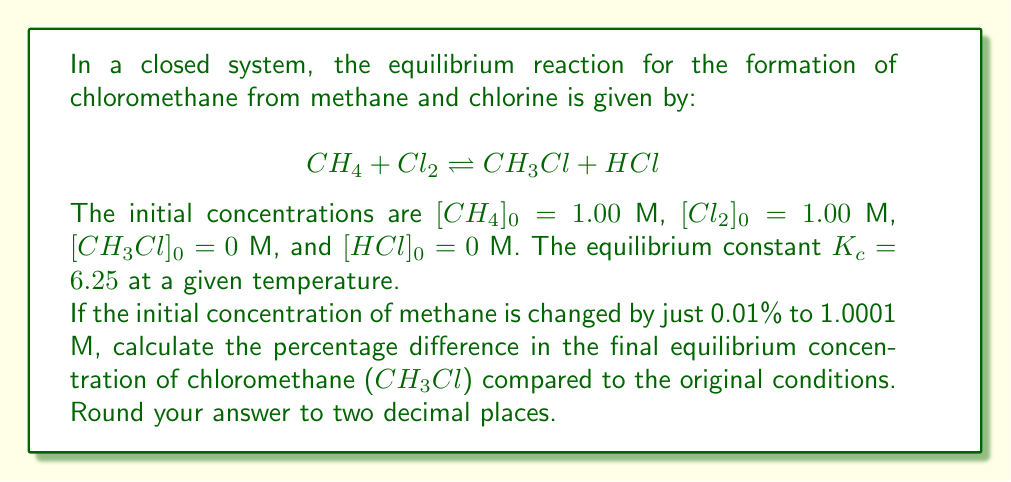Give your solution to this math problem. Let's approach this step-by-step:

1) First, let's solve for the equilibrium concentrations with the original initial conditions:

   Let $x$ be the amount of $CH_4$ and $Cl_2$ that reacts.

   $K_c = \frac{[CH_3Cl][HCl]}{[CH_4][Cl_2]} = 6.25$

   $6.25 = \frac{x^2}{(1-x)(1-x)} = \frac{x^2}{(1-x)^2}$

2) Solving this equation:

   $\sqrt{6.25} = \frac{x}{1-x}$
   $2.5 = \frac{x}{1-x}$
   $2.5 - 2.5x = x$
   $2.5 = 3.5x$
   $x = \frac{2.5}{3.5} = 0.7143$ M

3) So, at equilibrium:
   $[CH_3Cl] = [HCl] = 0.7143$ M
   $[CH_4] = [Cl_2] = 1 - 0.7143 = 0.2857$ M

4) Now, let's solve for the new equilibrium with $[CH_4]_0 = 1.0001$ M:

   $6.25 = \frac{y^2}{(1.0001-y)(1-y)}$

5) Solving this equation numerically (it's a bit more complex), we get:
   $y = 0.7144$ M

6) So, the new $[CH_3Cl] = 0.7144$ M

7) Calculate the percentage difference:

   $\text{Percentage difference} = \frac{0.7144 - 0.7143}{0.7143} \times 100\% = 0.014\%$
Answer: 0.01% 